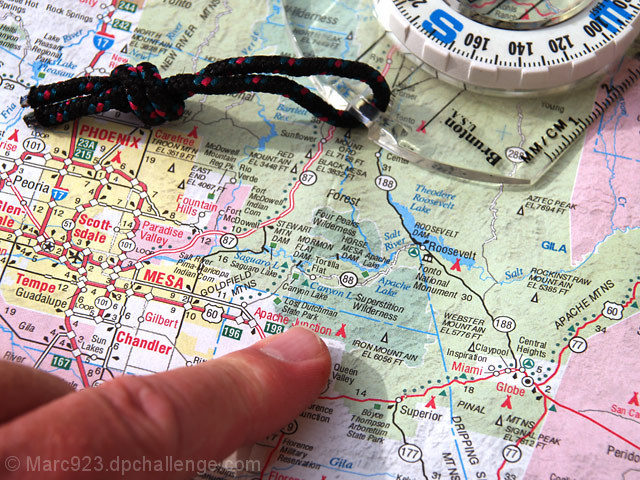Can you describe the type of compass shown in the image and its apparent use? The compass in the image appears to be a traditional orienteering compass, used for navigation. It has a rotating bezel marked with degrees and a magnetic needle to align with Earth's magnetic field, indicating the cardinal directions. How do you use such a compass for navigation? To use this compass, one would first align the compass needle with the magnetic north indicator on the bezel. Then, holding the compass level, rotate yourself and the map until the map's north aligns with the compass's indicated north. Now, the map should be oriented to true north, allowing you to navigate to your desired location. 